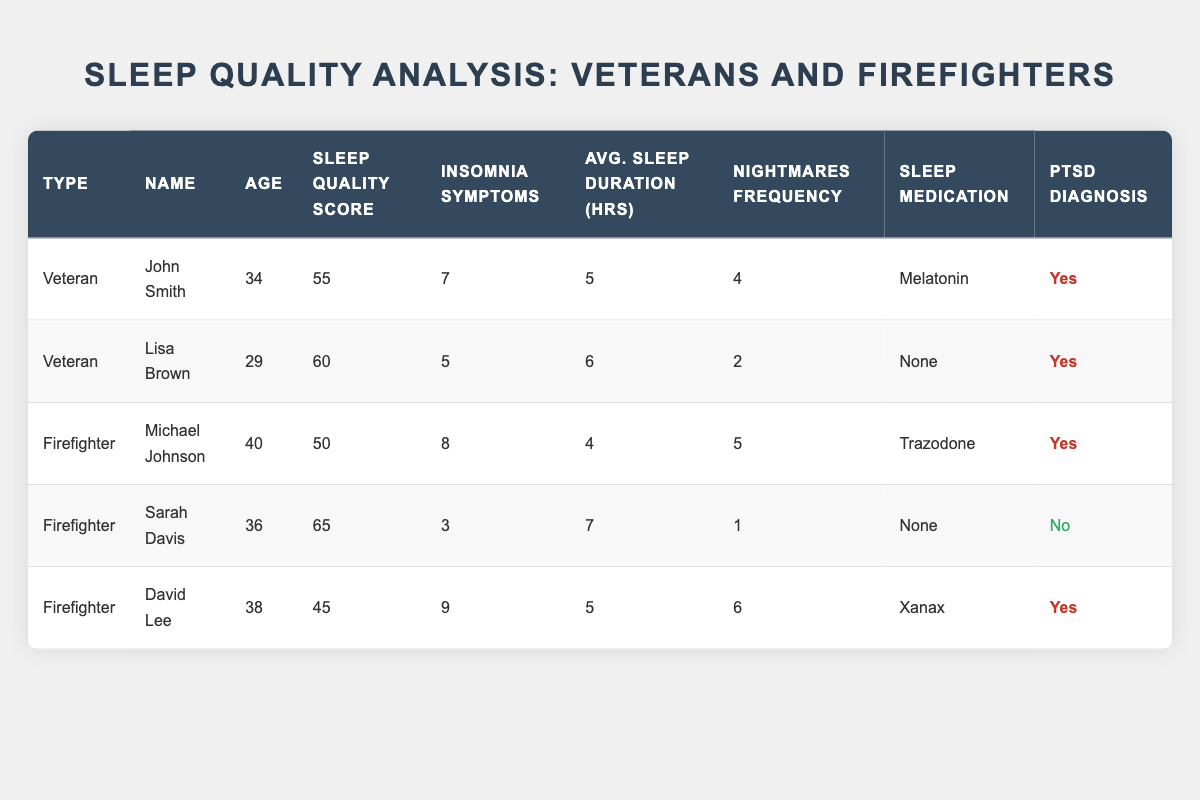What is the sleep quality score of Sarah Davis? In the table under the Firefighter category, Sarah Davis has a sleep quality score listed as 65.
Answer: 65 Which participant has the highest insomnia symptoms? By examining the insomnia symptoms column, David Lee has the highest reported symptoms with a score of 9.
Answer: 9 What is the average sleep duration for veterans in the table? The data shows average sleep duration for veterans: John Smith has 5 hours, and Lisa Brown has 6 hours. Adding these (5 + 6) gives 11 hours. Dividing this sum by 2 participants results in an average sleep duration of 11/2 = 5.5 hours.
Answer: 5.5 Do any participants take sleep medication? Looking at the sleep medication column, John Smith takes Melatonin, Michael Johnson takes Trazodone, and David Lee takes Xanax. Therefore, there are participants who take sleep medication.
Answer: Yes Which group has a participant with a sleep quality score below 50? Checking each participant's sleep quality score, David Lee has a score of 45, which is below 50, and he is categorized as a firefighter.
Answer: Yes What is the difference in sleep quality scores between John Smith and Michael Johnson? John's score is 55 and Michael's score is 50. To calculate the difference, subtract Michael's score from John's: 55 - 50 = 5.
Answer: 5 How many participants have a PTSD diagnosis among firefighters? In the table, Michael Johnson and David Lee are the only firefighters listed with a PTSD diagnosis (marked as Yes). Thus, there are 2 firefighters with PTSD.
Answer: 2 Which participant had the least number of nightmares? Comparing the nightmares frequency for all participants, Sarah Davis has the least frequency of 1 nightmare, making her the participant with the least.
Answer: 1 What is the average sleep quality score of all participants in the study? The sleep quality scores are 55, 60, 50, 65, and 45. Adding these scores gives 275. Dividing by the total number of participants (5): 275/5 = 55.
Answer: 55 